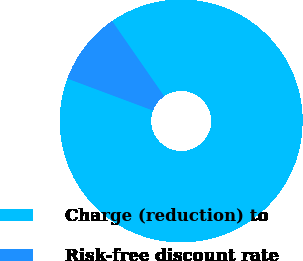Convert chart to OTSL. <chart><loc_0><loc_0><loc_500><loc_500><pie_chart><fcel>Charge (reduction) to<fcel>Risk-free discount rate<nl><fcel>90.32%<fcel>9.68%<nl></chart> 